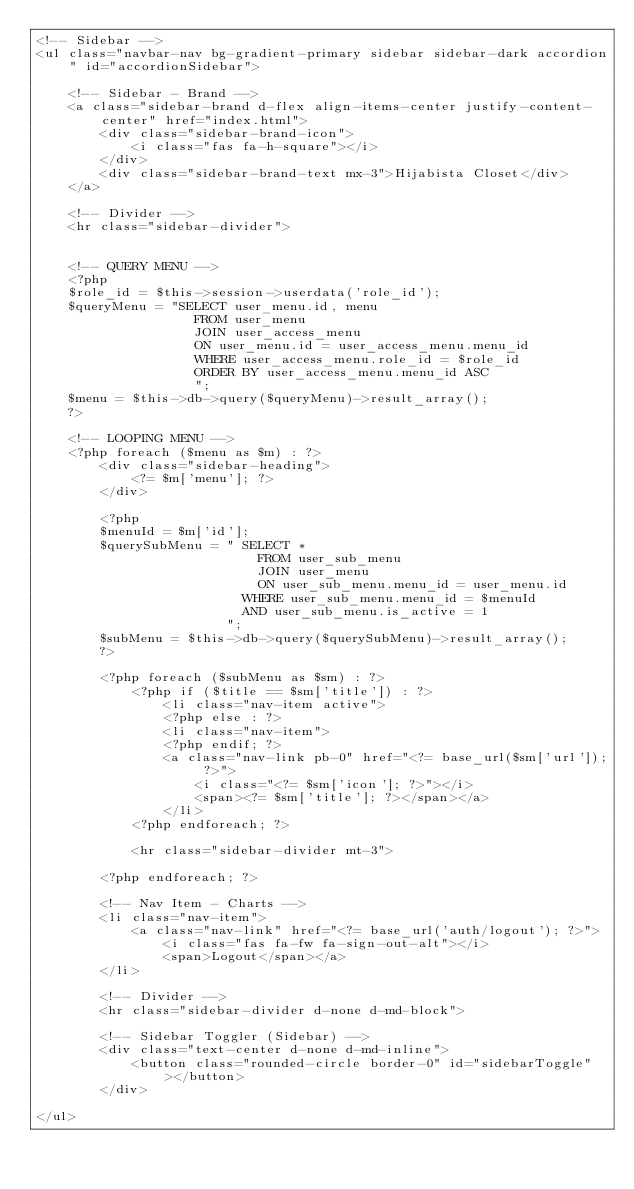Convert code to text. <code><loc_0><loc_0><loc_500><loc_500><_PHP_><!-- Sidebar -->
<ul class="navbar-nav bg-gradient-primary sidebar sidebar-dark accordion" id="accordionSidebar">

    <!-- Sidebar - Brand -->
    <a class="sidebar-brand d-flex align-items-center justify-content-center" href="index.html">
        <div class="sidebar-brand-icon">
            <i class="fas fa-h-square"></i>
        </div>
        <div class="sidebar-brand-text mx-3">Hijabista Closet</div>
    </a>

    <!-- Divider -->
    <hr class="sidebar-divider">


    <!-- QUERY MENU -->
    <?php
    $role_id = $this->session->userdata('role_id');
    $queryMenu = "SELECT user_menu.id, menu
                    FROM user_menu
                    JOIN user_access_menu
                    ON user_menu.id = user_access_menu.menu_id
                    WHERE user_access_menu.role_id = $role_id
                    ORDER BY user_access_menu.menu_id ASC
                    ";
    $menu = $this->db->query($queryMenu)->result_array();
    ?>

    <!-- LOOPING MENU -->
    <?php foreach ($menu as $m) : ?>
        <div class="sidebar-heading">
            <?= $m['menu']; ?>
        </div>

        <?php
        $menuId = $m['id'];
        $querySubMenu = " SELECT *
                            FROM user_sub_menu 
                            JOIN user_menu
                            ON user_sub_menu.menu_id = user_menu.id
                          WHERE user_sub_menu.menu_id = $menuId
                          AND user_sub_menu.is_active = 1
                        ";
        $subMenu = $this->db->query($querySubMenu)->result_array();
        ?>

        <?php foreach ($subMenu as $sm) : ?>
            <?php if ($title == $sm['title']) : ?>
                <li class="nav-item active">
                <?php else : ?>
                <li class="nav-item">
                <?php endif; ?>
                <a class="nav-link pb-0" href="<?= base_url($sm['url']); ?>">
                    <i class="<?= $sm['icon']; ?>"></i>
                    <span><?= $sm['title']; ?></span></a>
                </li>
            <?php endforeach; ?>

            <hr class="sidebar-divider mt-3">

        <?php endforeach; ?>

        <!-- Nav Item - Charts -->
        <li class="nav-item">
            <a class="nav-link" href="<?= base_url('auth/logout'); ?>">
                <i class="fas fa-fw fa-sign-out-alt"></i>
                <span>Logout</span></a>
        </li>

        <!-- Divider -->
        <hr class="sidebar-divider d-none d-md-block">

        <!-- Sidebar Toggler (Sidebar) -->
        <div class="text-center d-none d-md-inline">
            <button class="rounded-circle border-0" id="sidebarToggle"></button>
        </div>

</ul></code> 